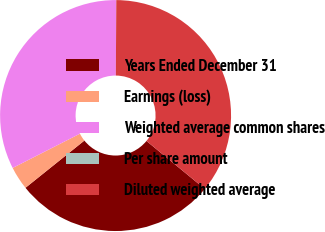Convert chart. <chart><loc_0><loc_0><loc_500><loc_500><pie_chart><fcel>Years Ended December 31<fcel>Earnings (loss)<fcel>Weighted average common shares<fcel>Per share amount<fcel>Diluted weighted average<nl><fcel>28.29%<fcel>3.26%<fcel>32.6%<fcel>0.0%<fcel>35.86%<nl></chart> 